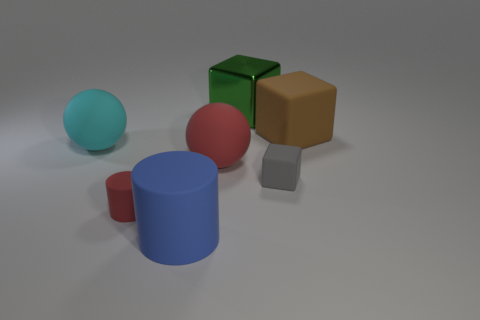Subtract all big blocks. How many blocks are left? 1 Add 1 yellow cylinders. How many objects exist? 8 Subtract all cubes. How many objects are left? 4 Subtract all yellow matte cylinders. Subtract all tiny red cylinders. How many objects are left? 6 Add 4 large blocks. How many large blocks are left? 6 Add 4 large purple matte objects. How many large purple matte objects exist? 4 Subtract 0 gray cylinders. How many objects are left? 7 